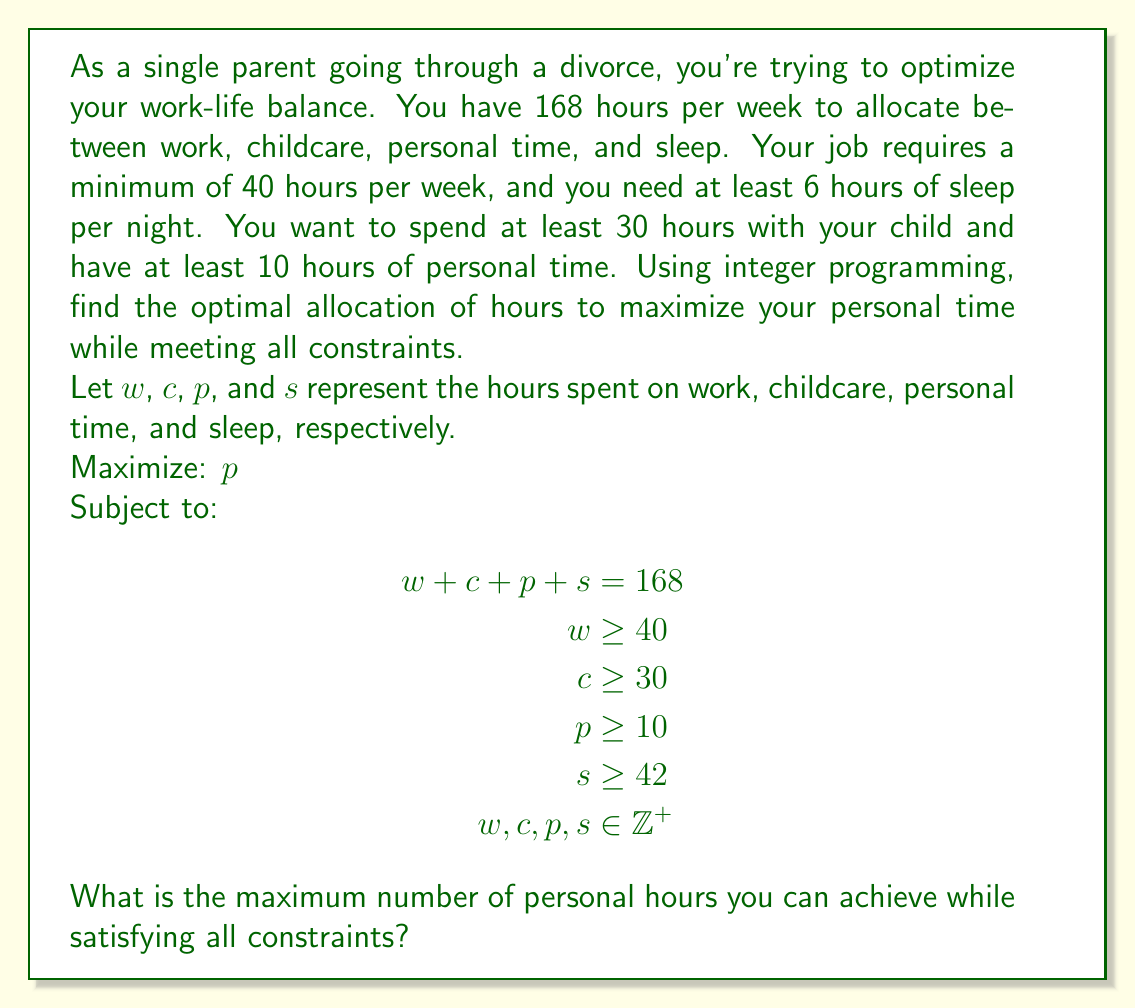Teach me how to tackle this problem. To solve this integer programming problem, we'll use the following steps:

1) First, let's identify our constraints:
   - Total hours: $w + c + p + s = 168$
   - Minimum work hours: $w \geq 40$
   - Minimum childcare hours: $c \geq 30$
   - Minimum personal hours: $p \geq 10$
   - Minimum sleep hours: $s \geq 42$
   - All variables must be positive integers

2) Our objective is to maximize $p$ (personal time).

3) We can start by assigning the minimum values to each variable:
   $w = 40$, $c = 30$, $p = 10$, $s = 42$

4) This accounts for $40 + 30 + 10 + 42 = 122$ hours.

5) We have $168 - 122 = 46$ hours left to allocate.

6) Since we're maximizing personal time, all these remaining hours should go to $p$.

7) Therefore, the optimal solution is:
   $w = 40$, $c = 30$, $p = 10 + 46 = 56$, $s = 42$

8) We can verify that this solution satisfies all constraints:
   - Total hours: $40 + 30 + 56 + 42 = 168$
   - All individual constraints are met
   - All variables are positive integers

Thus, the maximum number of personal hours achievable is 56.
Answer: 56 hours 